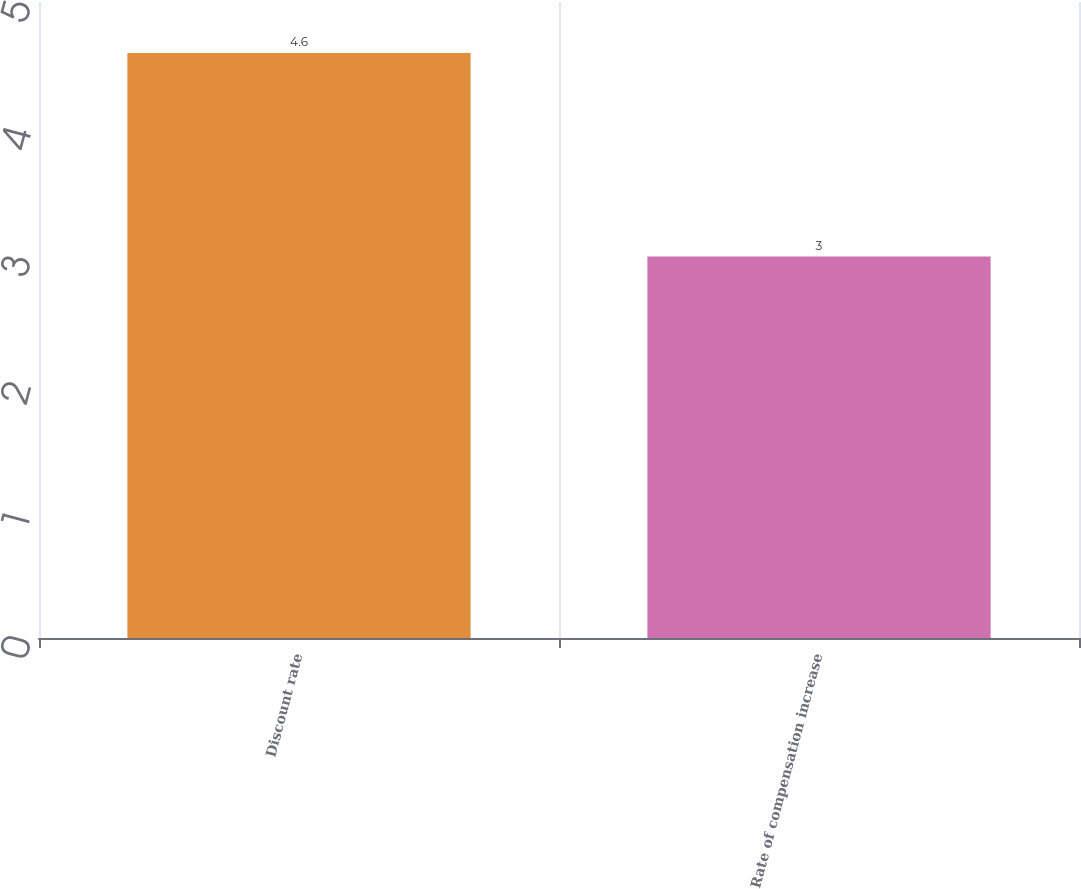Convert chart to OTSL. <chart><loc_0><loc_0><loc_500><loc_500><bar_chart><fcel>Discount rate<fcel>Rate of compensation increase<nl><fcel>4.6<fcel>3<nl></chart> 